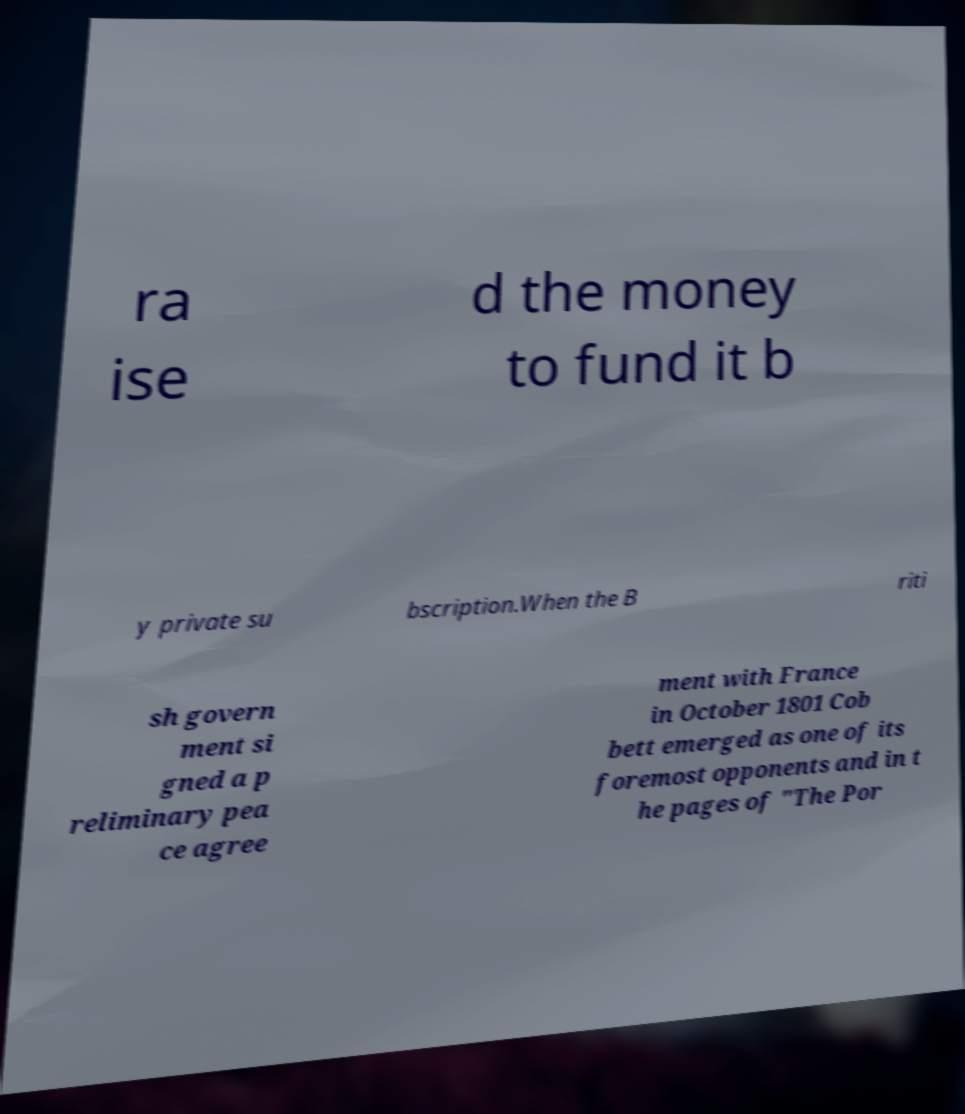Please read and relay the text visible in this image. What does it say? ra ise d the money to fund it b y private su bscription.When the B riti sh govern ment si gned a p reliminary pea ce agree ment with France in October 1801 Cob bett emerged as one of its foremost opponents and in t he pages of "The Por 